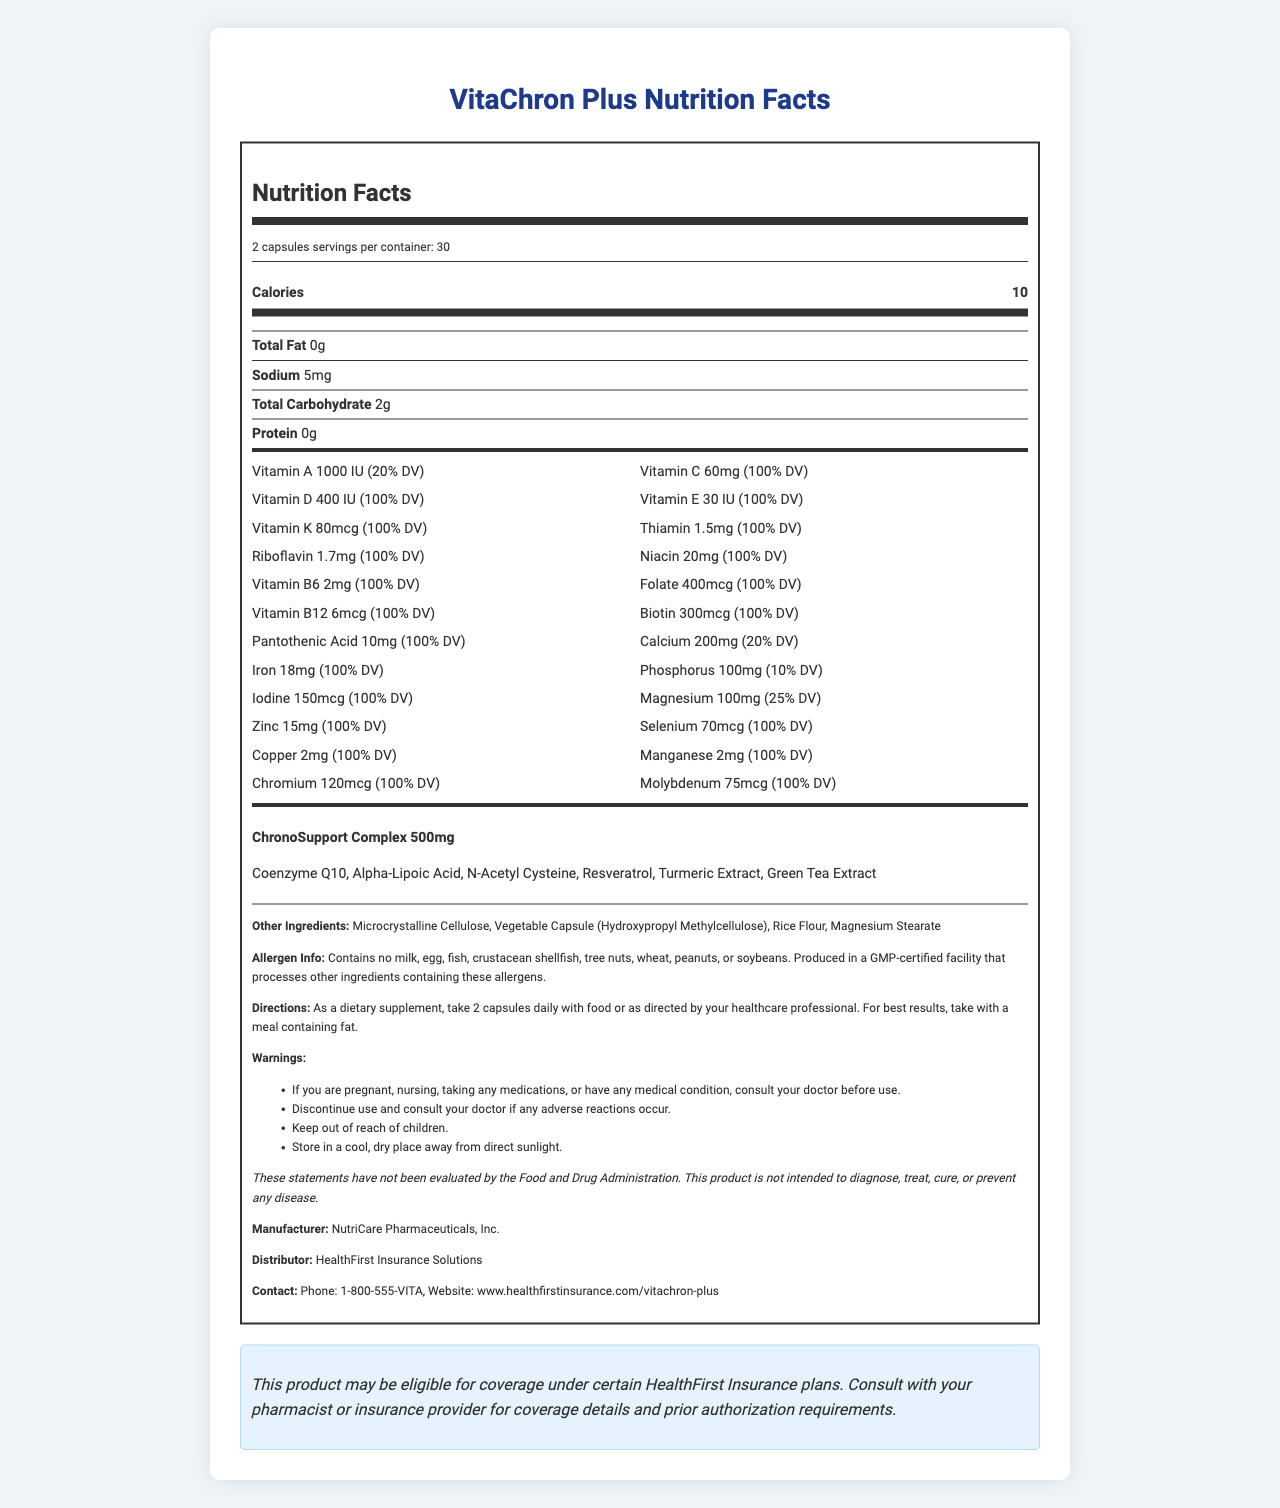what is the serving size for VitaChron Plus? The serving size information is explicitly stated under the "serving info" section, which indicates "2 capsules."
Answer: 2 capsules how many calories are in each serving of VitaChron Plus? The calorie content per serving is specified directly under the "calorie info" section, which shows "Calories 10."
Answer: 10 calories which vitamins in VitaChron Plus provide 100% of the daily value? These vitamins and minerals are listed with 100% DV next to their amounts.
Answer: Vitamin C, Vitamin D, Vitamin E, Vitamin K, Thiamin, Riboflavin, Niacin, Vitamin B6, Folate, Vitamin B12, Biotin, Pantothenic Acid, Iodine, Zinc, Selenium, Copper, Manganese, Chromium, Molybdenum how much iron is in one serving of VitaChron Plus? The amount of iron per serving is provided in the "vitamin-minerals" section, specifically listed as "Iron 18mg (100% DV)."
Answer: 18mg what are the directions for taking VitaChron Plus? The directions for use are clearly stated in the "Directions" section.
Answer: As a dietary supplement, take 2 capsules daily with food or as directed by your healthcare professional. For best results, take with a meal containing fat. does VitaChron Plus contain any common allergens like milk, egg, or soybeans? The allergen information section states, "Contains no milk, egg, fish, crustacean shellfish, tree nuts, wheat, peanuts, or soybeans."
Answer: No who distributes VitaChron Plus? A. NutriCare Pharmaceuticals, Inc. B. HealthFirst Insurance Solutions C. VitaCare Direct The distributor is listed as "HealthFirst Insurance Solutions" in the document.
Answer: B what is the total amount of vitamins and minerals listed in VitaChron Plus? A. 20 B. 23 C. 26 D. 29 There are 23 vitamins and minerals listed under the "vitamin-minerals" section.
Answer: B can VitaChron Plus cure chronic conditions? The FDA disclaimer states that the product is not intended to diagnose, treat, cure, or prevent any disease.
Answer: No summarize the main purpose of the document. The document is structured to inform consumers about the nutritional content and usage details of the supplement, ensuring they understand how to utilize it effectively and are aware of all relevant warnings and disclaimers.
Answer: The document provides detailed nutrition facts and other relevant information about VitaChron Plus, a specialized dietary supplement designed for patients with chronic conditions. It outlines the serving size, nutrients per serving, proprietary blend components, direction for use, allergen info, manufacturers and distributors, and warnings. It also includes an insurance coverage note. is green tea extract one of the ingredients in VitaChron Plus? Green Tea Extract is listed as one of the ingredients in the "ChronoSupport Complex" proprietary blend.
Answer: Yes how many capsules are in one container of VitaChron Plus? The servings per container is 30, and the serving size is 2 capsules. Therefore, the total number of capsules in one container is 30 servings x 2 capsules per serving = 60 capsules.
Answer: 60 capsules what should you do if you experience adverse reactions to VitaChron Plus? This information is included in the "Warnings" section of the document.
Answer: Discontinue use and consult your doctor are there any storage instructions for VitaChron Plus? The storage instruction states to "Store in a cool, dry place away from direct sunlight."
Answer: Yes what is the manufacturer's phone number? The contact information section specifies the phone number as "1-800-555-VITA."
Answer: 1-800-555-VITA can you find the price of VitaChron Plus in the document? The document does not provide any information regarding the price of VitaChron Plus.
Answer: Not enough information 